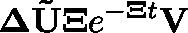<formula> <loc_0><loc_0><loc_500><loc_500>\Delta \tilde { U } \Xi e ^ { - \mathbf { \Xi } t } V</formula> 